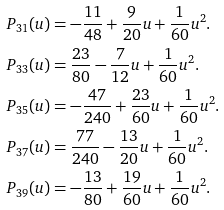Convert formula to latex. <formula><loc_0><loc_0><loc_500><loc_500>P _ { 3 1 } ( u ) & = - \frac { 1 1 } { 4 8 } + \frac { 9 } { 2 0 } u + \frac { 1 } { 6 0 } u ^ { 2 } . \\ P _ { 3 3 } ( u ) & = \frac { 2 3 } { 8 0 } - \frac { 7 } { 1 2 } u + \frac { 1 } { 6 0 } u ^ { 2 } . \\ P _ { 3 5 } ( u ) & = - \frac { 4 7 } { 2 4 0 } + \frac { 2 3 } { 6 0 } u + \frac { 1 } { 6 0 } u ^ { 2 } . \\ P _ { 3 7 } ( u ) & = \frac { 7 7 } { 2 4 0 } - \frac { 1 3 } { 2 0 } u + \frac { 1 } { 6 0 } u ^ { 2 } . \\ P _ { 3 9 } ( u ) & = - \frac { 1 3 } { 8 0 } + \frac { 1 9 } { 6 0 } u + \frac { 1 } { 6 0 } u ^ { 2 } . \\</formula> 